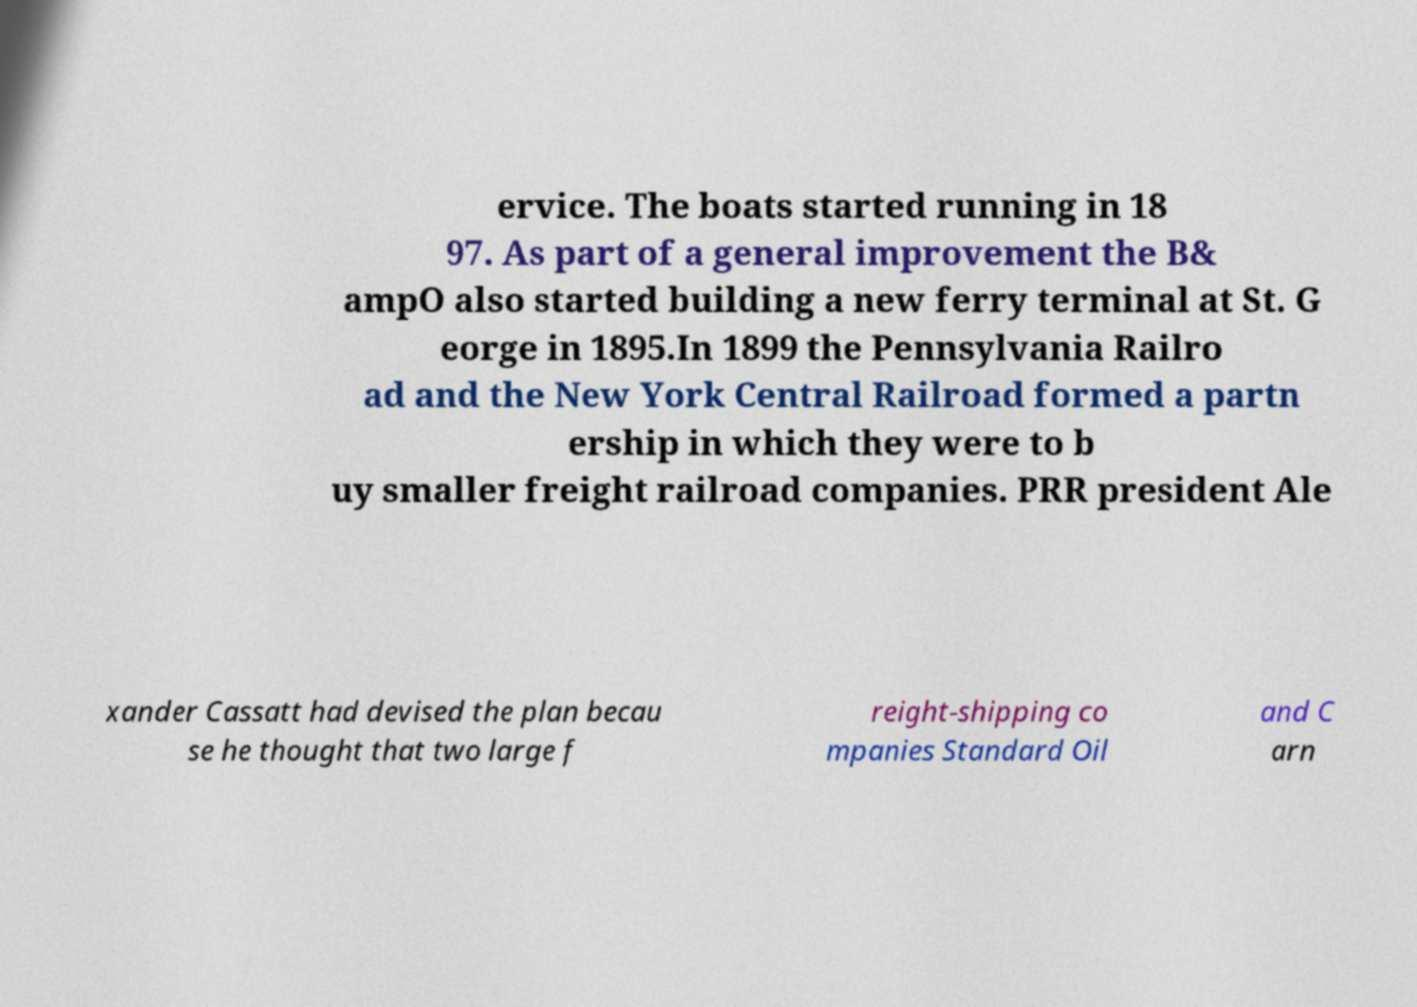Could you assist in decoding the text presented in this image and type it out clearly? ervice. The boats started running in 18 97. As part of a general improvement the B& ampO also started building a new ferry terminal at St. G eorge in 1895.In 1899 the Pennsylvania Railro ad and the New York Central Railroad formed a partn ership in which they were to b uy smaller freight railroad companies. PRR president Ale xander Cassatt had devised the plan becau se he thought that two large f reight-shipping co mpanies Standard Oil and C arn 